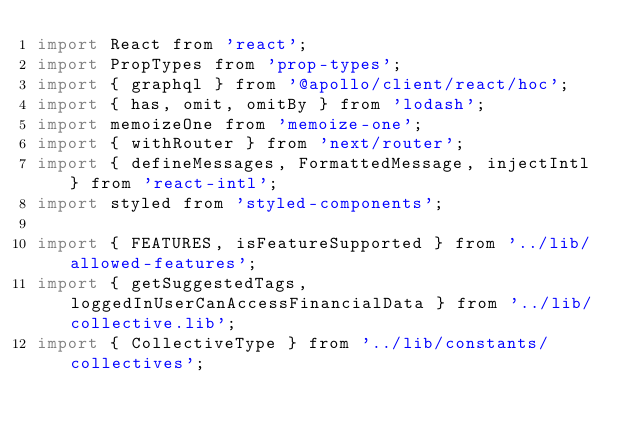Convert code to text. <code><loc_0><loc_0><loc_500><loc_500><_JavaScript_>import React from 'react';
import PropTypes from 'prop-types';
import { graphql } from '@apollo/client/react/hoc';
import { has, omit, omitBy } from 'lodash';
import memoizeOne from 'memoize-one';
import { withRouter } from 'next/router';
import { defineMessages, FormattedMessage, injectIntl } from 'react-intl';
import styled from 'styled-components';

import { FEATURES, isFeatureSupported } from '../lib/allowed-features';
import { getSuggestedTags, loggedInUserCanAccessFinancialData } from '../lib/collective.lib';
import { CollectiveType } from '../lib/constants/collectives';</code> 